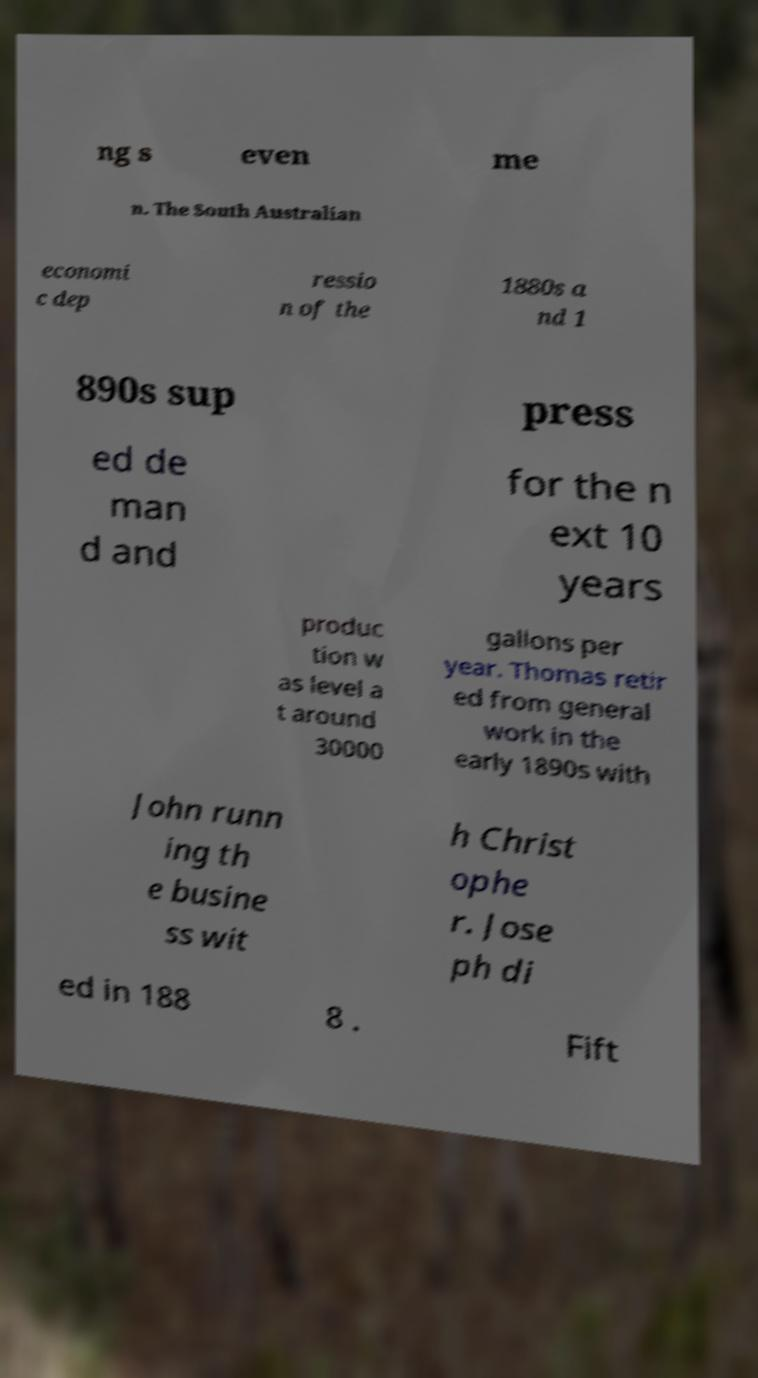Could you extract and type out the text from this image? ng s even me n. The South Australian economi c dep ressio n of the 1880s a nd 1 890s sup press ed de man d and for the n ext 10 years produc tion w as level a t around 30000 gallons per year. Thomas retir ed from general work in the early 1890s with John runn ing th e busine ss wit h Christ ophe r. Jose ph di ed in 188 8 . Fift 